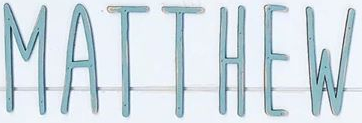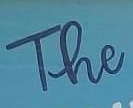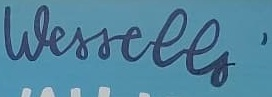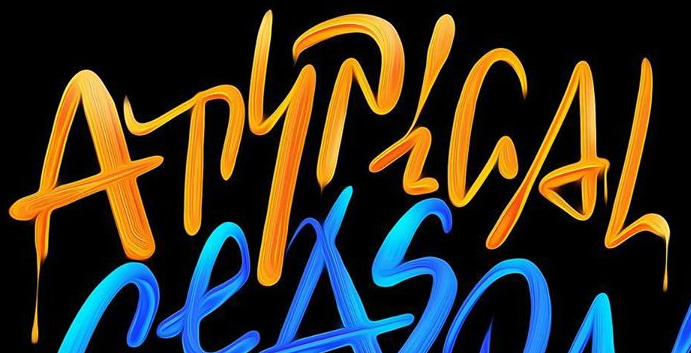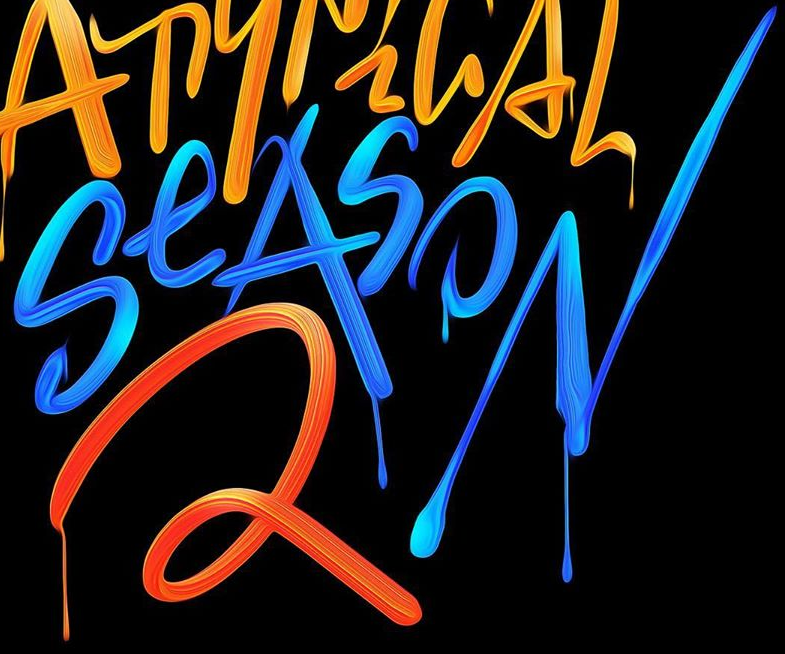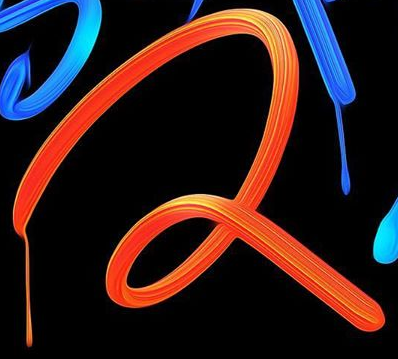Transcribe the words shown in these images in order, separated by a semicolon. MATTHEW; The; Wessells'; ATYPiGAL; SeASON; 2 